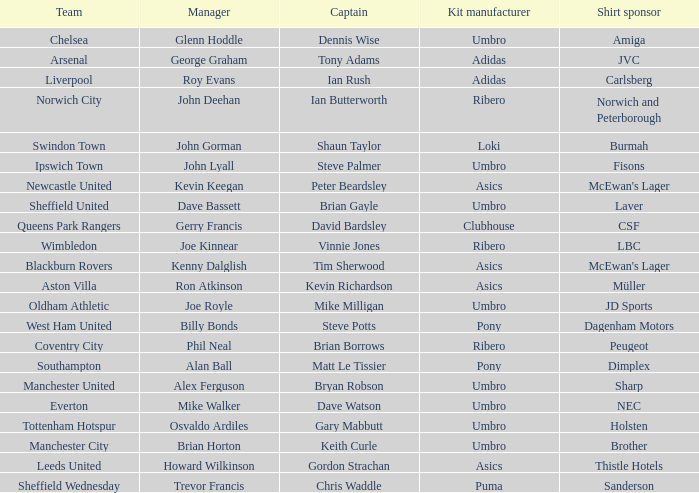Which manager has Manchester City as the team? Brian Horton. 